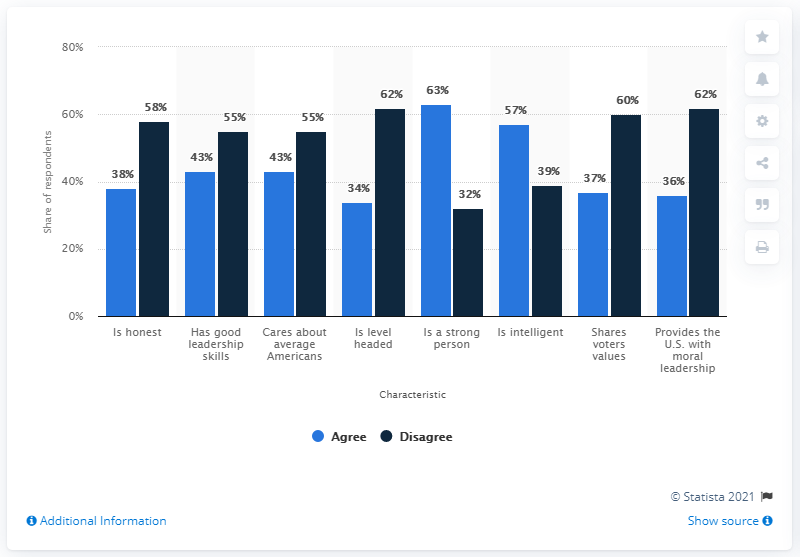Draw attention to some important aspects in this diagram. The difference between the shortest light blue bar and the tallest dark blue bar is 28. According to a survey conducted in July 2018, the highest share of voters in the United States who believe that President Trump possesses certain character traits is 63%. 